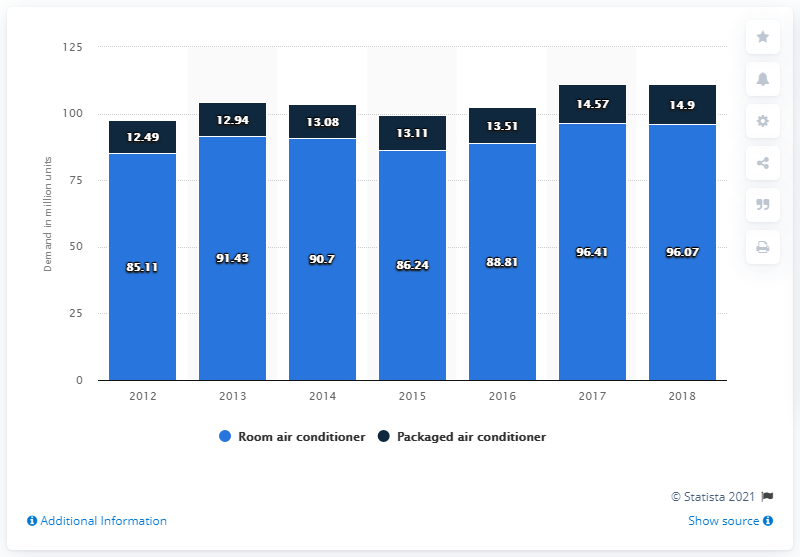Give some essential details in this illustration. In 2018, the global demand for room air conditioners was 96.07 units. 